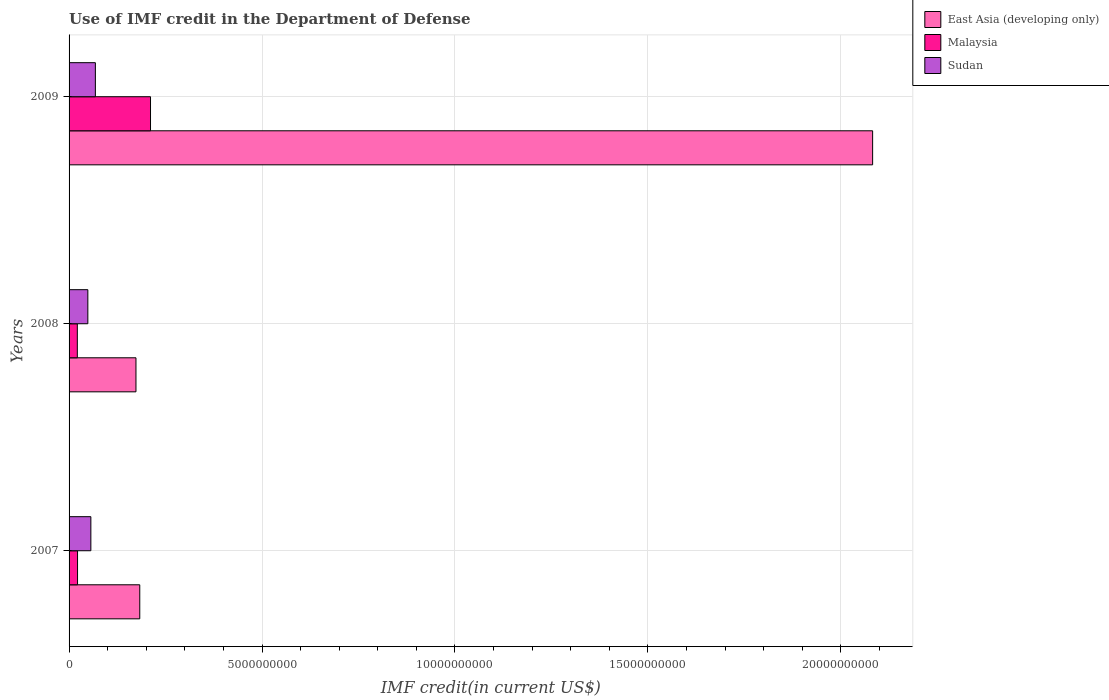How many different coloured bars are there?
Your answer should be compact. 3. Are the number of bars per tick equal to the number of legend labels?
Keep it short and to the point. Yes. Are the number of bars on each tick of the Y-axis equal?
Your answer should be compact. Yes. What is the IMF credit in the Department of Defense in Sudan in 2007?
Give a very brief answer. 5.65e+08. Across all years, what is the maximum IMF credit in the Department of Defense in Malaysia?
Offer a terse response. 2.11e+09. Across all years, what is the minimum IMF credit in the Department of Defense in Sudan?
Provide a succinct answer. 4.86e+08. What is the total IMF credit in the Department of Defense in East Asia (developing only) in the graph?
Your answer should be compact. 2.44e+1. What is the difference between the IMF credit in the Department of Defense in Malaysia in 2007 and that in 2008?
Provide a succinct answer. 5.56e+06. What is the difference between the IMF credit in the Department of Defense in East Asia (developing only) in 2009 and the IMF credit in the Department of Defense in Malaysia in 2008?
Ensure brevity in your answer.  2.06e+1. What is the average IMF credit in the Department of Defense in Malaysia per year?
Offer a very short reply. 8.48e+08. In the year 2009, what is the difference between the IMF credit in the Department of Defense in Malaysia and IMF credit in the Department of Defense in Sudan?
Your answer should be very brief. 1.43e+09. In how many years, is the IMF credit in the Department of Defense in Sudan greater than 9000000000 US$?
Make the answer very short. 0. What is the ratio of the IMF credit in the Department of Defense in Malaysia in 2008 to that in 2009?
Offer a terse response. 0.1. What is the difference between the highest and the second highest IMF credit in the Department of Defense in Sudan?
Give a very brief answer. 1.17e+08. What is the difference between the highest and the lowest IMF credit in the Department of Defense in Sudan?
Your response must be concise. 1.95e+08. In how many years, is the IMF credit in the Department of Defense in Sudan greater than the average IMF credit in the Department of Defense in Sudan taken over all years?
Make the answer very short. 1. Is the sum of the IMF credit in the Department of Defense in Malaysia in 2007 and 2009 greater than the maximum IMF credit in the Department of Defense in East Asia (developing only) across all years?
Your answer should be very brief. No. What does the 2nd bar from the top in 2008 represents?
Provide a succinct answer. Malaysia. What does the 1st bar from the bottom in 2008 represents?
Give a very brief answer. East Asia (developing only). Is it the case that in every year, the sum of the IMF credit in the Department of Defense in East Asia (developing only) and IMF credit in the Department of Defense in Sudan is greater than the IMF credit in the Department of Defense in Malaysia?
Your answer should be very brief. Yes. How many bars are there?
Your answer should be very brief. 9. Are the values on the major ticks of X-axis written in scientific E-notation?
Give a very brief answer. No. Does the graph contain grids?
Your answer should be very brief. Yes. How are the legend labels stacked?
Keep it short and to the point. Vertical. What is the title of the graph?
Offer a terse response. Use of IMF credit in the Department of Defense. Does "West Bank and Gaza" appear as one of the legend labels in the graph?
Your response must be concise. No. What is the label or title of the X-axis?
Your answer should be compact. IMF credit(in current US$). What is the IMF credit(in current US$) of East Asia (developing only) in 2007?
Offer a very short reply. 1.83e+09. What is the IMF credit(in current US$) in Malaysia in 2007?
Make the answer very short. 2.20e+08. What is the IMF credit(in current US$) of Sudan in 2007?
Give a very brief answer. 5.65e+08. What is the IMF credit(in current US$) of East Asia (developing only) in 2008?
Your answer should be very brief. 1.73e+09. What is the IMF credit(in current US$) of Malaysia in 2008?
Make the answer very short. 2.14e+08. What is the IMF credit(in current US$) in Sudan in 2008?
Your answer should be compact. 4.86e+08. What is the IMF credit(in current US$) of East Asia (developing only) in 2009?
Give a very brief answer. 2.08e+1. What is the IMF credit(in current US$) in Malaysia in 2009?
Offer a very short reply. 2.11e+09. What is the IMF credit(in current US$) of Sudan in 2009?
Make the answer very short. 6.82e+08. Across all years, what is the maximum IMF credit(in current US$) of East Asia (developing only)?
Provide a short and direct response. 2.08e+1. Across all years, what is the maximum IMF credit(in current US$) of Malaysia?
Your answer should be compact. 2.11e+09. Across all years, what is the maximum IMF credit(in current US$) of Sudan?
Your answer should be very brief. 6.82e+08. Across all years, what is the minimum IMF credit(in current US$) of East Asia (developing only)?
Your response must be concise. 1.73e+09. Across all years, what is the minimum IMF credit(in current US$) in Malaysia?
Your answer should be compact. 2.14e+08. Across all years, what is the minimum IMF credit(in current US$) of Sudan?
Make the answer very short. 4.86e+08. What is the total IMF credit(in current US$) of East Asia (developing only) in the graph?
Offer a very short reply. 2.44e+1. What is the total IMF credit(in current US$) of Malaysia in the graph?
Ensure brevity in your answer.  2.54e+09. What is the total IMF credit(in current US$) in Sudan in the graph?
Ensure brevity in your answer.  1.73e+09. What is the difference between the IMF credit(in current US$) in East Asia (developing only) in 2007 and that in 2008?
Give a very brief answer. 9.84e+07. What is the difference between the IMF credit(in current US$) in Malaysia in 2007 and that in 2008?
Your answer should be compact. 5.56e+06. What is the difference between the IMF credit(in current US$) of Sudan in 2007 and that in 2008?
Your answer should be very brief. 7.81e+07. What is the difference between the IMF credit(in current US$) in East Asia (developing only) in 2007 and that in 2009?
Ensure brevity in your answer.  -1.90e+1. What is the difference between the IMF credit(in current US$) of Malaysia in 2007 and that in 2009?
Make the answer very short. -1.89e+09. What is the difference between the IMF credit(in current US$) of Sudan in 2007 and that in 2009?
Your answer should be very brief. -1.17e+08. What is the difference between the IMF credit(in current US$) in East Asia (developing only) in 2008 and that in 2009?
Make the answer very short. -1.91e+1. What is the difference between the IMF credit(in current US$) in Malaysia in 2008 and that in 2009?
Provide a succinct answer. -1.90e+09. What is the difference between the IMF credit(in current US$) in Sudan in 2008 and that in 2009?
Your response must be concise. -1.95e+08. What is the difference between the IMF credit(in current US$) in East Asia (developing only) in 2007 and the IMF credit(in current US$) in Malaysia in 2008?
Provide a succinct answer. 1.62e+09. What is the difference between the IMF credit(in current US$) of East Asia (developing only) in 2007 and the IMF credit(in current US$) of Sudan in 2008?
Provide a short and direct response. 1.35e+09. What is the difference between the IMF credit(in current US$) in Malaysia in 2007 and the IMF credit(in current US$) in Sudan in 2008?
Make the answer very short. -2.67e+08. What is the difference between the IMF credit(in current US$) in East Asia (developing only) in 2007 and the IMF credit(in current US$) in Malaysia in 2009?
Provide a succinct answer. -2.78e+08. What is the difference between the IMF credit(in current US$) in East Asia (developing only) in 2007 and the IMF credit(in current US$) in Sudan in 2009?
Keep it short and to the point. 1.15e+09. What is the difference between the IMF credit(in current US$) of Malaysia in 2007 and the IMF credit(in current US$) of Sudan in 2009?
Give a very brief answer. -4.62e+08. What is the difference between the IMF credit(in current US$) in East Asia (developing only) in 2008 and the IMF credit(in current US$) in Malaysia in 2009?
Provide a short and direct response. -3.77e+08. What is the difference between the IMF credit(in current US$) of East Asia (developing only) in 2008 and the IMF credit(in current US$) of Sudan in 2009?
Your response must be concise. 1.05e+09. What is the difference between the IMF credit(in current US$) of Malaysia in 2008 and the IMF credit(in current US$) of Sudan in 2009?
Provide a short and direct response. -4.67e+08. What is the average IMF credit(in current US$) in East Asia (developing only) per year?
Give a very brief answer. 8.13e+09. What is the average IMF credit(in current US$) in Malaysia per year?
Offer a terse response. 8.48e+08. What is the average IMF credit(in current US$) of Sudan per year?
Make the answer very short. 5.78e+08. In the year 2007, what is the difference between the IMF credit(in current US$) of East Asia (developing only) and IMF credit(in current US$) of Malaysia?
Your answer should be very brief. 1.61e+09. In the year 2007, what is the difference between the IMF credit(in current US$) of East Asia (developing only) and IMF credit(in current US$) of Sudan?
Ensure brevity in your answer.  1.27e+09. In the year 2007, what is the difference between the IMF credit(in current US$) in Malaysia and IMF credit(in current US$) in Sudan?
Ensure brevity in your answer.  -3.45e+08. In the year 2008, what is the difference between the IMF credit(in current US$) in East Asia (developing only) and IMF credit(in current US$) in Malaysia?
Make the answer very short. 1.52e+09. In the year 2008, what is the difference between the IMF credit(in current US$) in East Asia (developing only) and IMF credit(in current US$) in Sudan?
Give a very brief answer. 1.25e+09. In the year 2008, what is the difference between the IMF credit(in current US$) of Malaysia and IMF credit(in current US$) of Sudan?
Make the answer very short. -2.72e+08. In the year 2009, what is the difference between the IMF credit(in current US$) in East Asia (developing only) and IMF credit(in current US$) in Malaysia?
Give a very brief answer. 1.87e+1. In the year 2009, what is the difference between the IMF credit(in current US$) of East Asia (developing only) and IMF credit(in current US$) of Sudan?
Keep it short and to the point. 2.01e+1. In the year 2009, what is the difference between the IMF credit(in current US$) of Malaysia and IMF credit(in current US$) of Sudan?
Keep it short and to the point. 1.43e+09. What is the ratio of the IMF credit(in current US$) in East Asia (developing only) in 2007 to that in 2008?
Provide a short and direct response. 1.06. What is the ratio of the IMF credit(in current US$) of Sudan in 2007 to that in 2008?
Your response must be concise. 1.16. What is the ratio of the IMF credit(in current US$) in East Asia (developing only) in 2007 to that in 2009?
Provide a succinct answer. 0.09. What is the ratio of the IMF credit(in current US$) in Malaysia in 2007 to that in 2009?
Offer a very short reply. 0.1. What is the ratio of the IMF credit(in current US$) of Sudan in 2007 to that in 2009?
Provide a short and direct response. 0.83. What is the ratio of the IMF credit(in current US$) in East Asia (developing only) in 2008 to that in 2009?
Keep it short and to the point. 0.08. What is the ratio of the IMF credit(in current US$) of Malaysia in 2008 to that in 2009?
Offer a terse response. 0.1. What is the ratio of the IMF credit(in current US$) of Sudan in 2008 to that in 2009?
Ensure brevity in your answer.  0.71. What is the difference between the highest and the second highest IMF credit(in current US$) in East Asia (developing only)?
Give a very brief answer. 1.90e+1. What is the difference between the highest and the second highest IMF credit(in current US$) of Malaysia?
Provide a short and direct response. 1.89e+09. What is the difference between the highest and the second highest IMF credit(in current US$) in Sudan?
Make the answer very short. 1.17e+08. What is the difference between the highest and the lowest IMF credit(in current US$) of East Asia (developing only)?
Offer a terse response. 1.91e+1. What is the difference between the highest and the lowest IMF credit(in current US$) in Malaysia?
Your answer should be compact. 1.90e+09. What is the difference between the highest and the lowest IMF credit(in current US$) in Sudan?
Keep it short and to the point. 1.95e+08. 